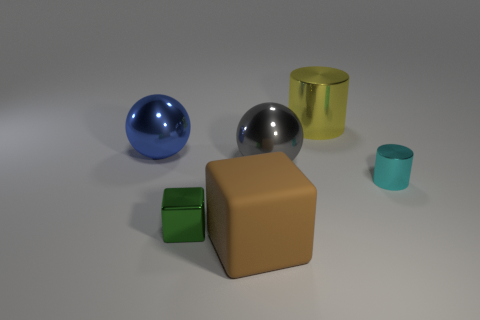Add 3 gray metal spheres. How many objects exist? 9 Subtract all cyan cylinders. How many cylinders are left? 1 Subtract 1 cubes. How many cubes are left? 1 Subtract 0 red blocks. How many objects are left? 6 Subtract all brown cubes. Subtract all cyan balls. How many cubes are left? 1 Subtract all brown spheres. How many gray cylinders are left? 0 Subtract all matte cubes. Subtract all big blue balls. How many objects are left? 4 Add 6 big objects. How many big objects are left? 10 Add 2 small cyan blocks. How many small cyan blocks exist? 2 